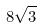<formula> <loc_0><loc_0><loc_500><loc_500>8 \sqrt { 3 }</formula> 